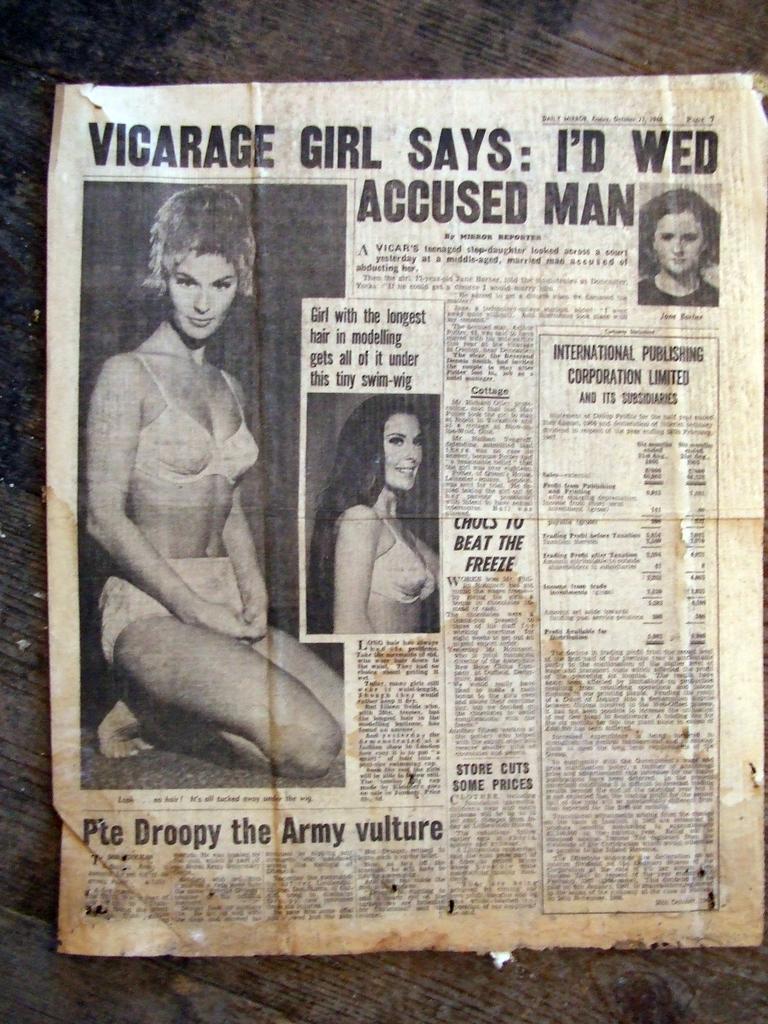Describe this image in one or two sentences. In this picture I can see the newspaper. I can see images and text. 